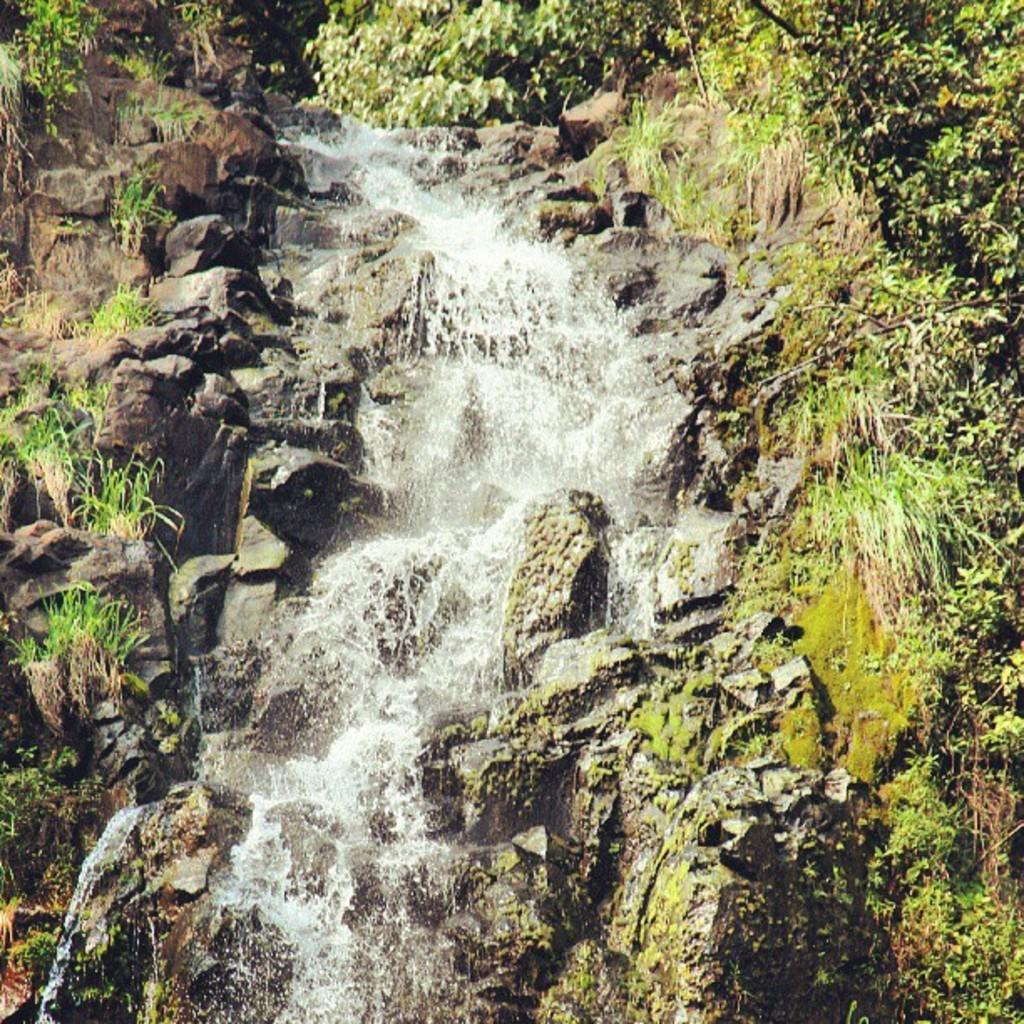What is the main feature in the center of the image? There is a waterfall in the center of the image. What can be seen surrounding the waterfall? There is greenery around the area around the waterfall in the image. What type of shoes are the waterfall wearing in the image? Waterfalls do not wear shoes, as they are natural formations and not living beings. 